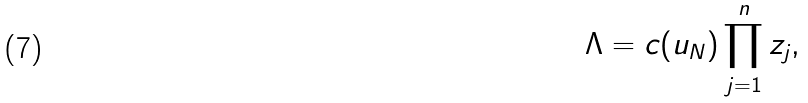Convert formula to latex. <formula><loc_0><loc_0><loc_500><loc_500>\Lambda = c ( u _ { N } ) \prod _ { j = 1 } ^ { n } z _ { j } ,</formula> 